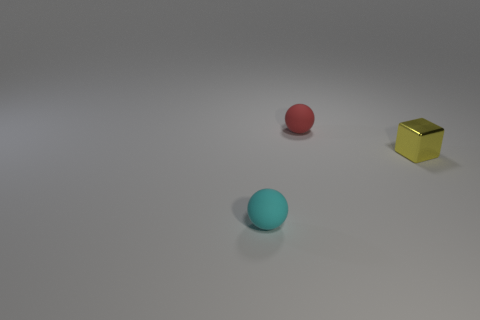Add 3 blue rubber cubes. How many objects exist? 6 Subtract all balls. How many objects are left? 1 Subtract all tiny yellow shiny cubes. Subtract all cubes. How many objects are left? 1 Add 3 small metallic things. How many small metallic things are left? 4 Add 3 large red blocks. How many large red blocks exist? 3 Subtract 0 gray cylinders. How many objects are left? 3 